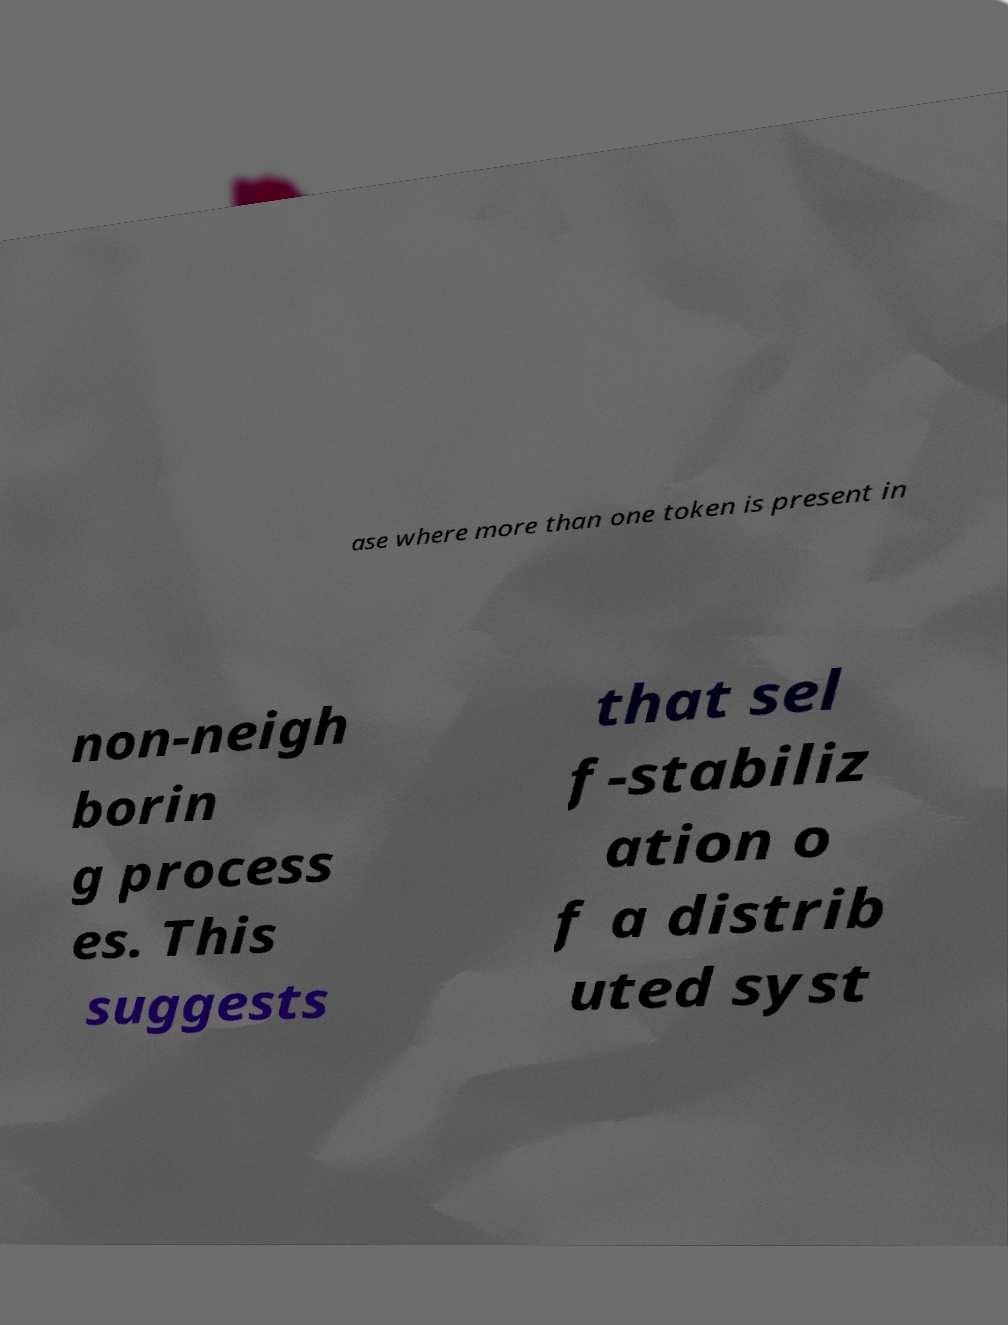Can you read and provide the text displayed in the image?This photo seems to have some interesting text. Can you extract and type it out for me? ase where more than one token is present in non-neigh borin g process es. This suggests that sel f-stabiliz ation o f a distrib uted syst 